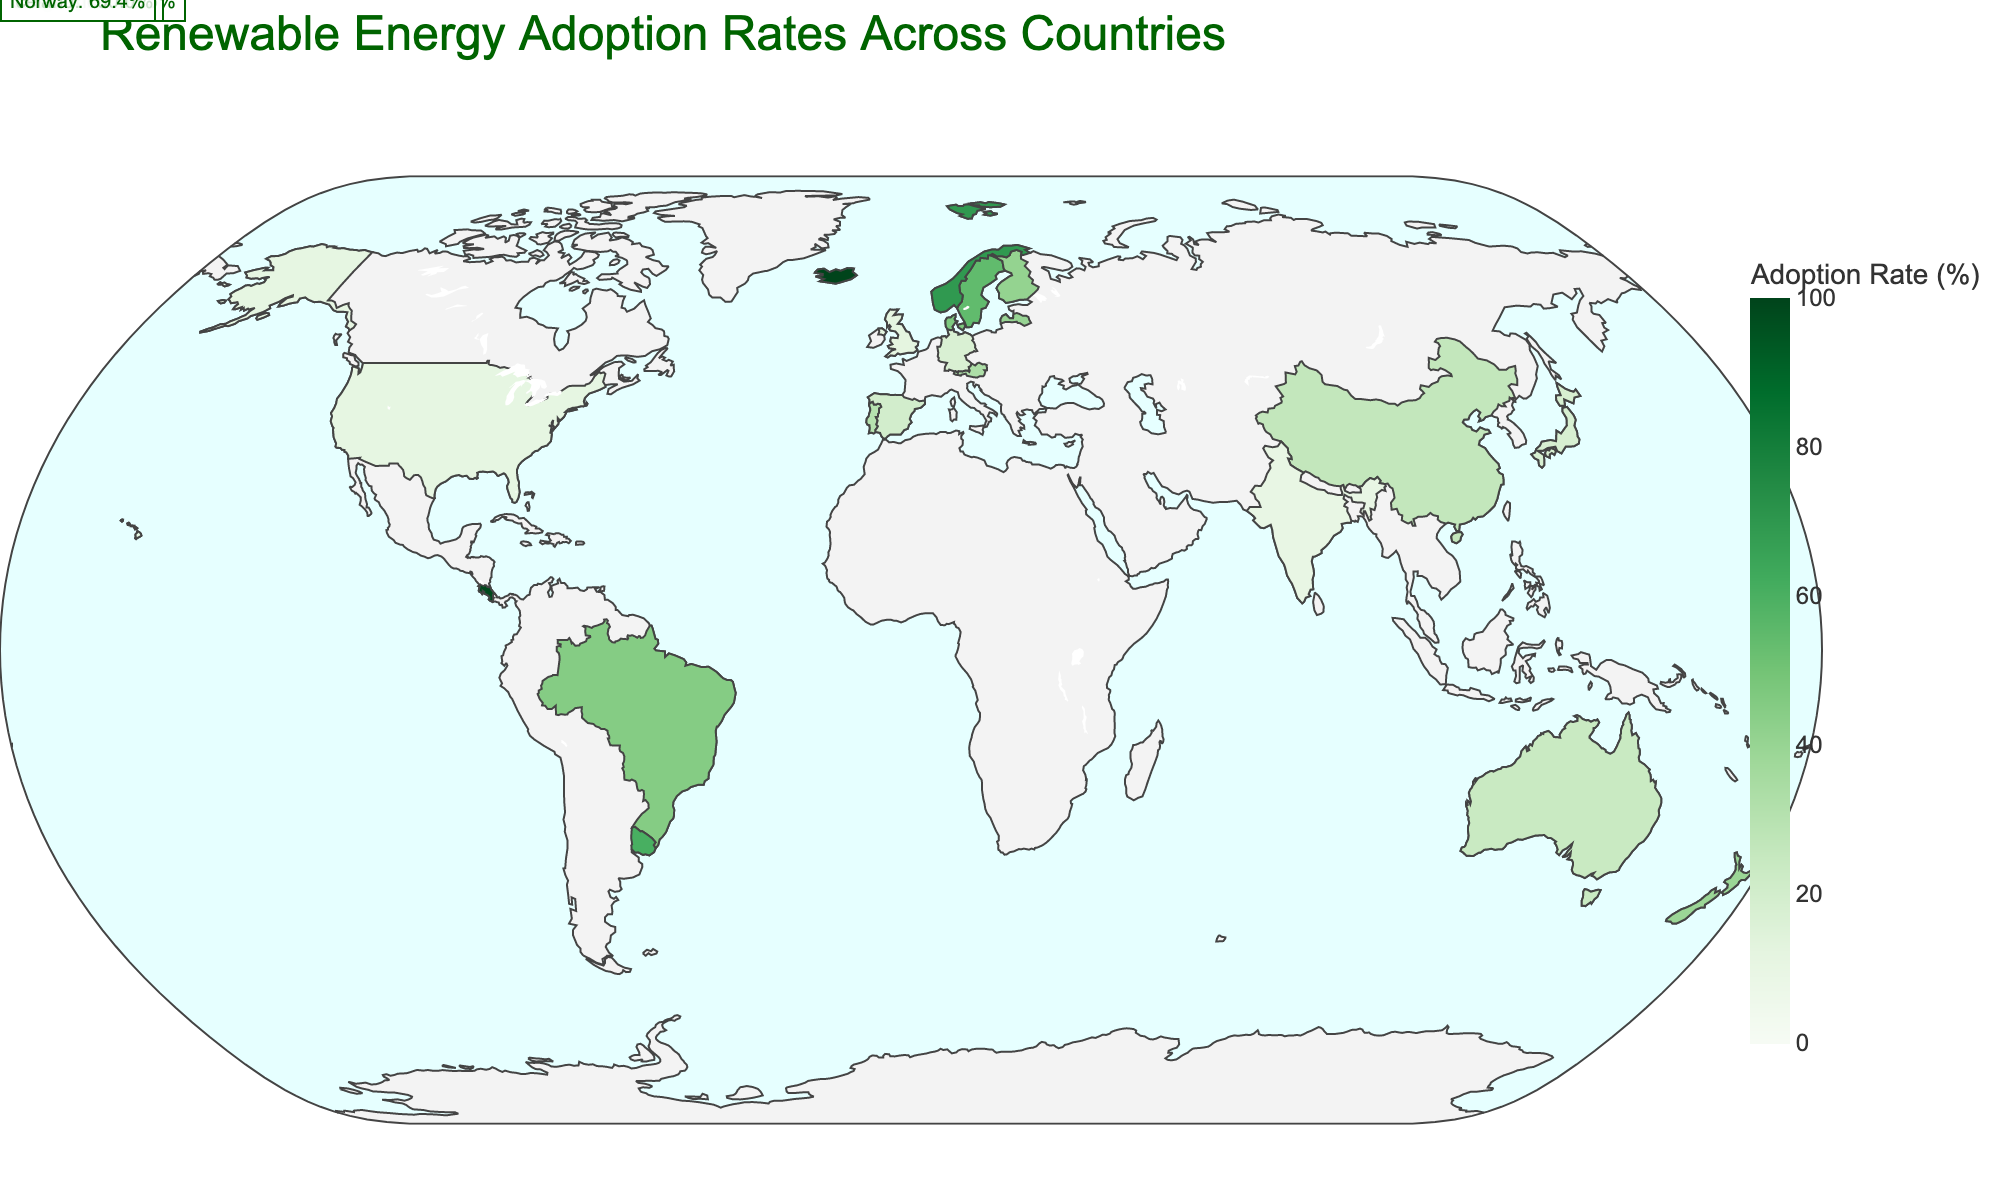Which country has the highest renewable energy adoption rate? The highest renewable energy adoption rate is represented by the darkest shade of green on the map. Referring to the figure, we find the country with the 100% adoption rate, which is colored the darkest.
Answer: Iceland What is the title of the choropleth map? The title of the chart is typically placed at the top of the figure. Here, it is clearly visible within the designated title layout area.
Answer: Renewable Energy Adoption Rates Across Countries Which three countries have adoption rates of over 50%? To determine this, we identify countries that are annotated with their adoption rate above 50%. From the figure, those countries are Uruguay, Costa Rica, and Iceland.
Answer: Uruguay, Costa Rica, Iceland Among Sweden and Denmark, which country has a higher adoption rate? Examining the colors and annotations of both countries on the map, we compare the adoption rates. Sweden's rate is 54.6%, while Denmark's is 47.1%.
Answer: Sweden What is the average adoption rate of the Latin American countries listed? The Latin American countries in the figure are Brazil (45.3%), Uruguay (60.7%), and Costa Rica (98.5%). The average is calculated as (45.3 + 60.7 + 98.5) / 3 = 68.17%.
Answer: 68.17% How does the adoption rate of Germany compare to that of Japan? Comparing the annotations or color intensity for these two countries, Germany has an adoption rate of 17.4%, and Japan's rate is 18.5%. Thus, Japan has a slightly higher rate.
Answer: Japan Which continent has the highest concentration of countries with high renewable energy adoption rates? Observing the distribution, Europe has multiple countries with higher rates: Sweden, Denmark, Finland, Latvia, and Norway.
Answer: Europe What percentage of renewable energy adoption does New Zealand have, and how does it compare to that of Australia? New Zealand's rate is 39.1%, and Australia's rate is 24.1%, as indicated by their respective colors/annotations on the map. New Zealand has a higher adoption rate.
Answer: New Zealand: 39.1%, higher Identify and compare the adoption rates of the United States and China. The United States shows an 11.6% rate, while China shows 26.4%. Comparison indicates China has a higher adoption rate.
Answer: China: 26.4%, USA: 11.6% What is the median renewable energy adoption rate among the countries listed? Listing the rates in ascending order: 10.1, 11.6, 12.3, 17.4, 18.5, 20.4, 24.1, 26.4, 30.6, 33.4, 39.1, 40.3, 41.2, 45.3, 47.1, 54.6, 60.7, 69.4, 98.5, 100.0. Median remains between two middle values (30.6, 33.4). Average of these is (30.6 + 33.4) / 2 = 32.0.
Answer: 32.0% 